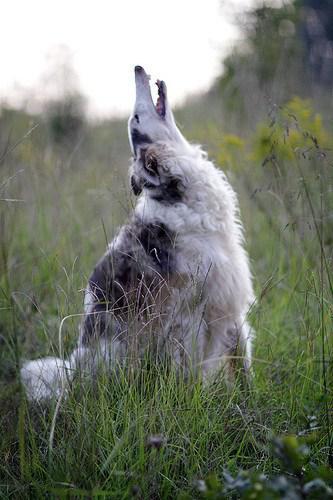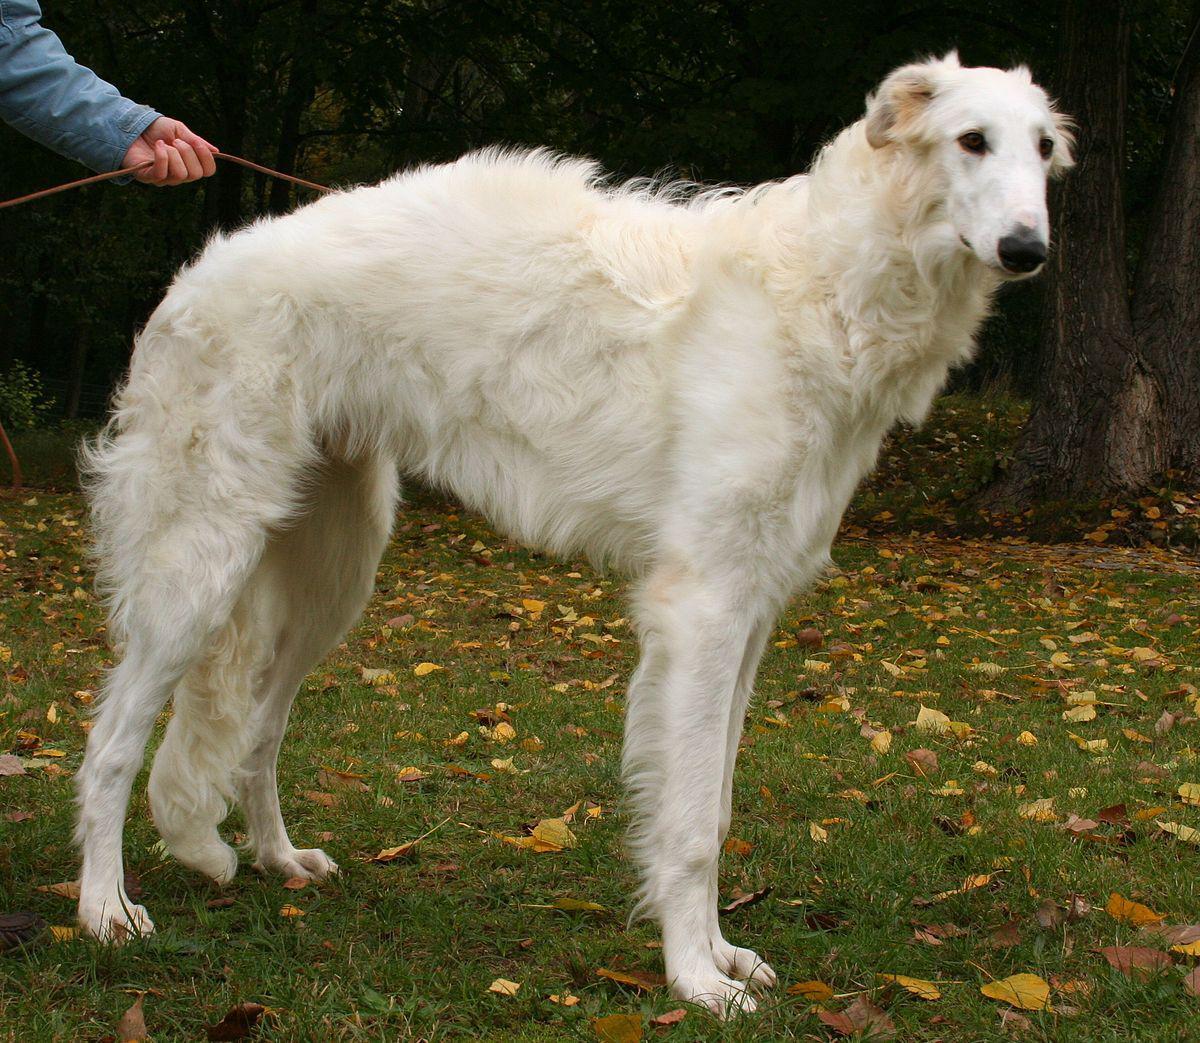The first image is the image on the left, the second image is the image on the right. Examine the images to the left and right. Is the description "A woman's legs are seen next to dog." accurate? Answer yes or no. No. The first image is the image on the left, the second image is the image on the right. Analyze the images presented: Is the assertion "There is only one dog in the left image and it is looking left." valid? Answer yes or no. No. The first image is the image on the left, the second image is the image on the right. For the images displayed, is the sentence "There is more than one dog in the image on the left." factually correct? Answer yes or no. No. 